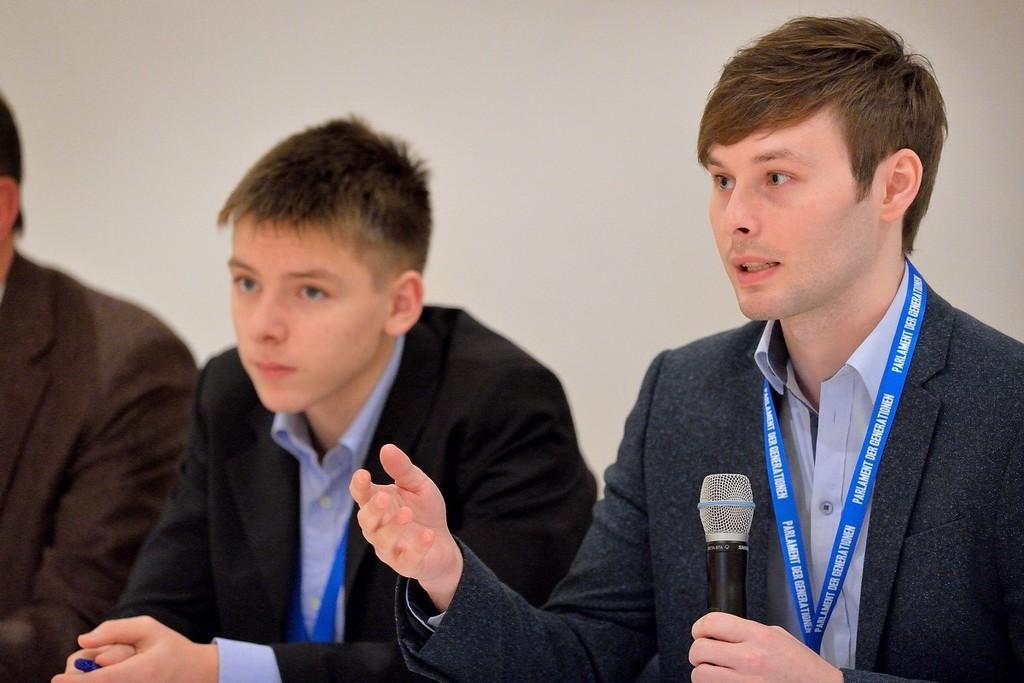In one or two sentences, can you explain what this image depicts? In this image i can see 3 persons, the person on the right corner is holding a microphone in his hand. 